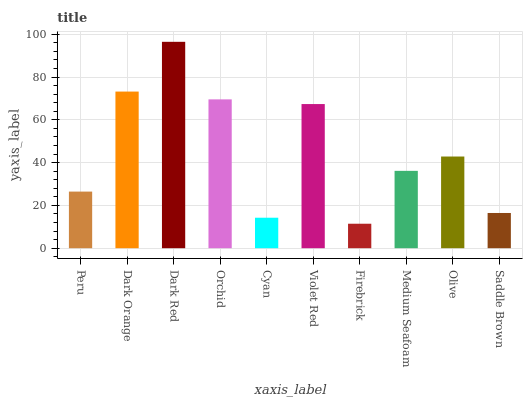Is Firebrick the minimum?
Answer yes or no. Yes. Is Dark Red the maximum?
Answer yes or no. Yes. Is Dark Orange the minimum?
Answer yes or no. No. Is Dark Orange the maximum?
Answer yes or no. No. Is Dark Orange greater than Peru?
Answer yes or no. Yes. Is Peru less than Dark Orange?
Answer yes or no. Yes. Is Peru greater than Dark Orange?
Answer yes or no. No. Is Dark Orange less than Peru?
Answer yes or no. No. Is Olive the high median?
Answer yes or no. Yes. Is Medium Seafoam the low median?
Answer yes or no. Yes. Is Cyan the high median?
Answer yes or no. No. Is Saddle Brown the low median?
Answer yes or no. No. 